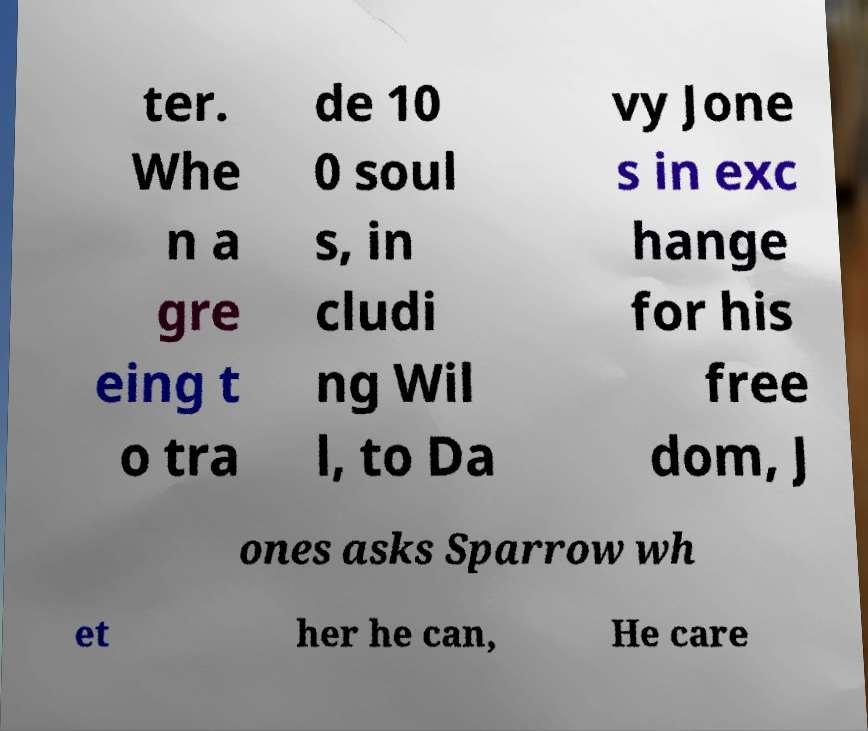There's text embedded in this image that I need extracted. Can you transcribe it verbatim? ter. Whe n a gre eing t o tra de 10 0 soul s, in cludi ng Wil l, to Da vy Jone s in exc hange for his free dom, J ones asks Sparrow wh et her he can, He care 